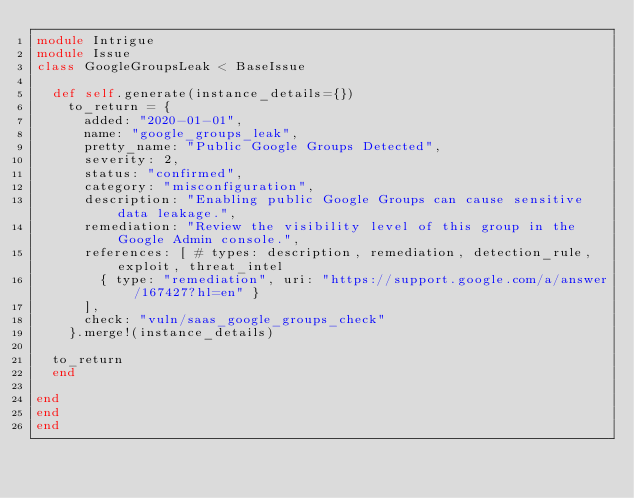<code> <loc_0><loc_0><loc_500><loc_500><_Ruby_>module Intrigue
module Issue
class GoogleGroupsLeak < BaseIssue

  def self.generate(instance_details={})
    to_return = {
      added: "2020-01-01",
      name: "google_groups_leak",
      pretty_name: "Public Google Groups Detected",
      severity: 2,
      status: "confirmed",
      category: "misconfiguration",
      description: "Enabling public Google Groups can cause sensitive data leakage.",
      remediation: "Review the visibility level of this group in the Google Admin console.",
      references: [ # types: description, remediation, detection_rule, exploit, threat_intel
        { type: "remediation", uri: "https://support.google.com/a/answer/167427?hl=en" }
      ], 
      check: "vuln/saas_google_groups_check"
    }.merge!(instance_details)

  to_return
  end

end
end
end
</code> 